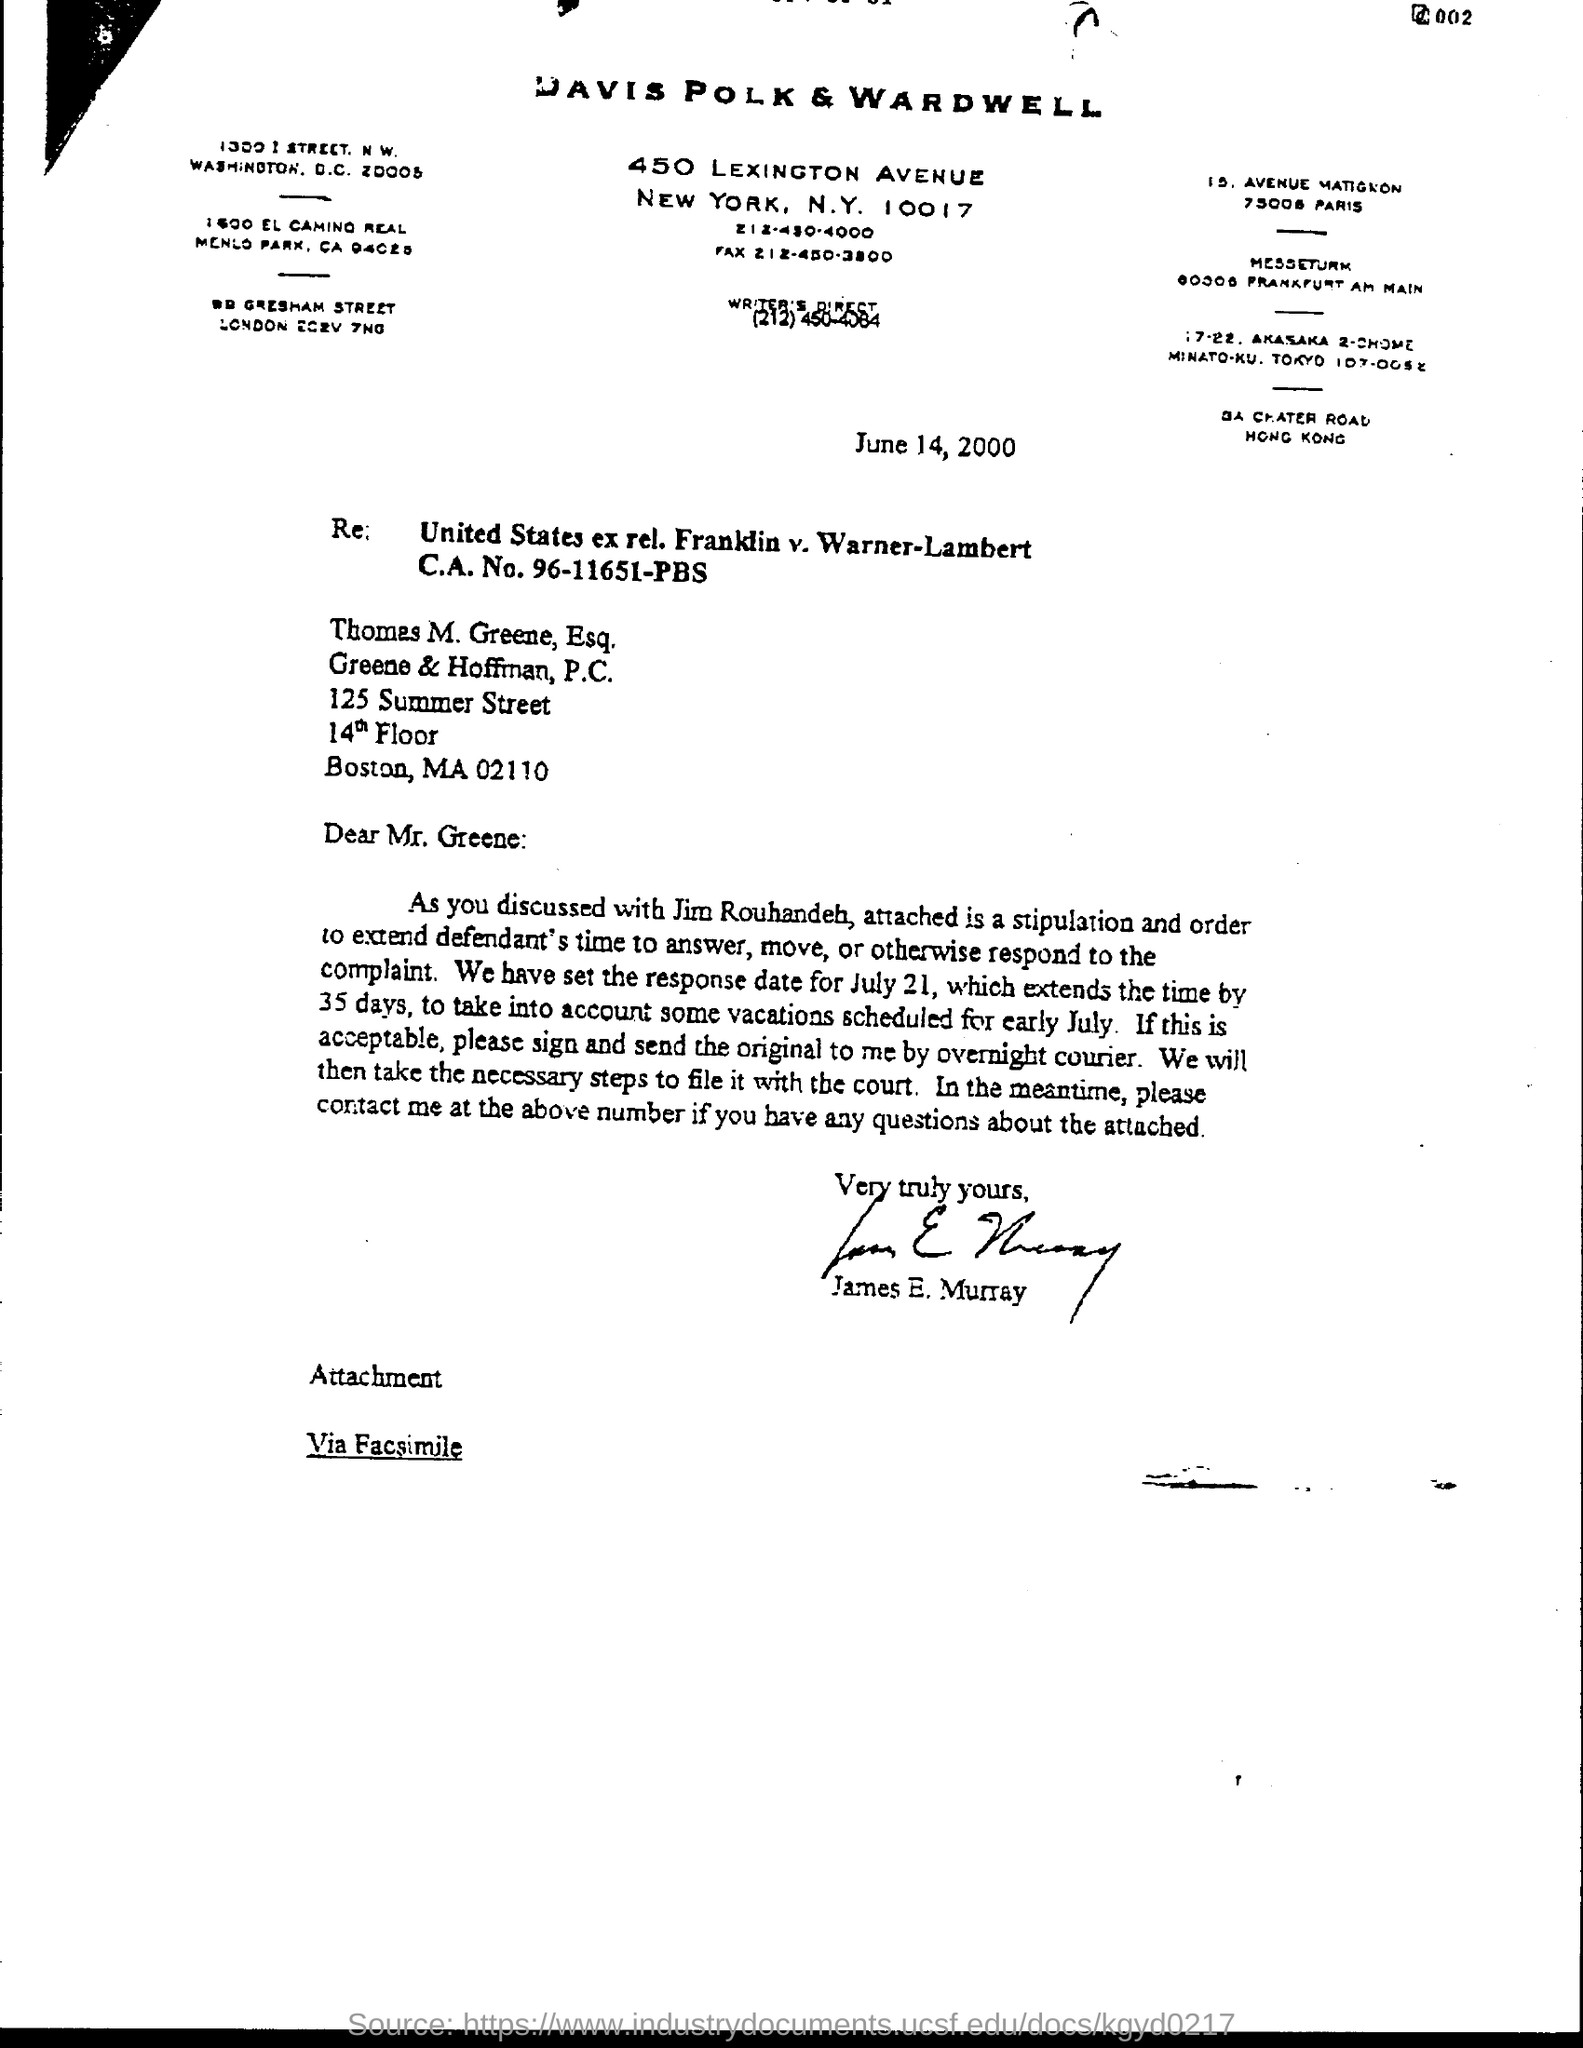Draw attention to some important aspects in this diagram. The letter is addressed to Thomas M. Greene, Esq.. James E. Murray wrote this letter. 